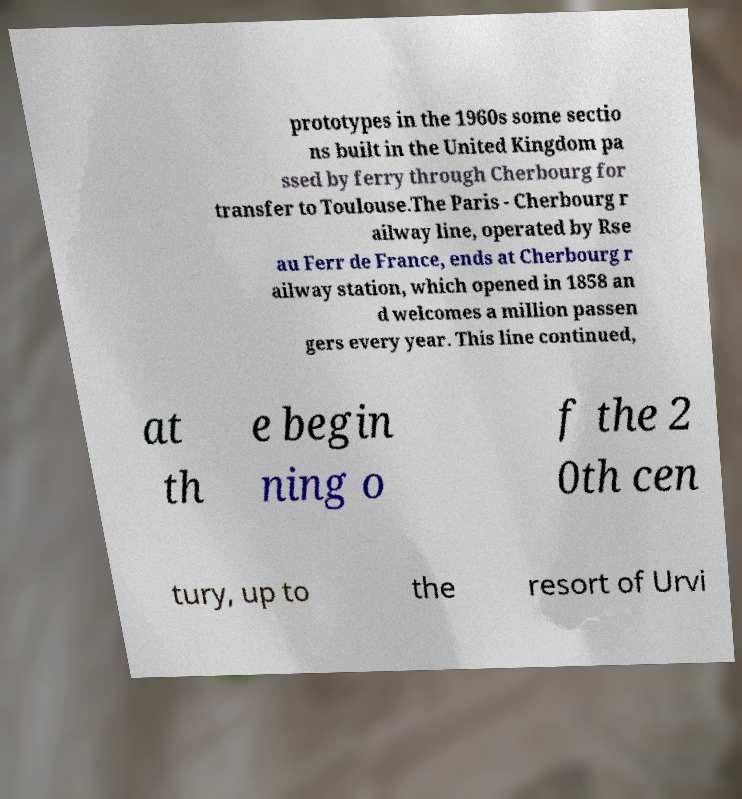Could you assist in decoding the text presented in this image and type it out clearly? prototypes in the 1960s some sectio ns built in the United Kingdom pa ssed by ferry through Cherbourg for transfer to Toulouse.The Paris - Cherbourg r ailway line, operated by Rse au Ferr de France, ends at Cherbourg r ailway station, which opened in 1858 an d welcomes a million passen gers every year. This line continued, at th e begin ning o f the 2 0th cen tury, up to the resort of Urvi 